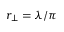<formula> <loc_0><loc_0><loc_500><loc_500>r _ { \perp } = \lambda / \pi</formula> 